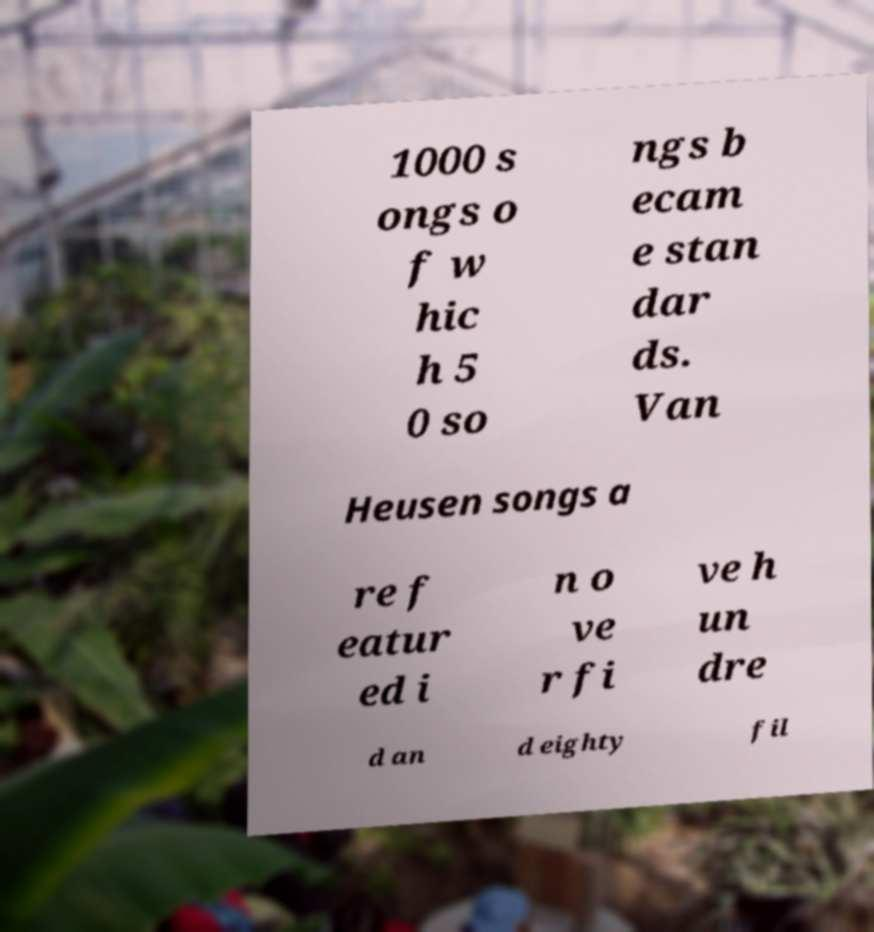For documentation purposes, I need the text within this image transcribed. Could you provide that? 1000 s ongs o f w hic h 5 0 so ngs b ecam e stan dar ds. Van Heusen songs a re f eatur ed i n o ve r fi ve h un dre d an d eighty fil 